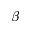<formula> <loc_0><loc_0><loc_500><loc_500>\beta</formula> 